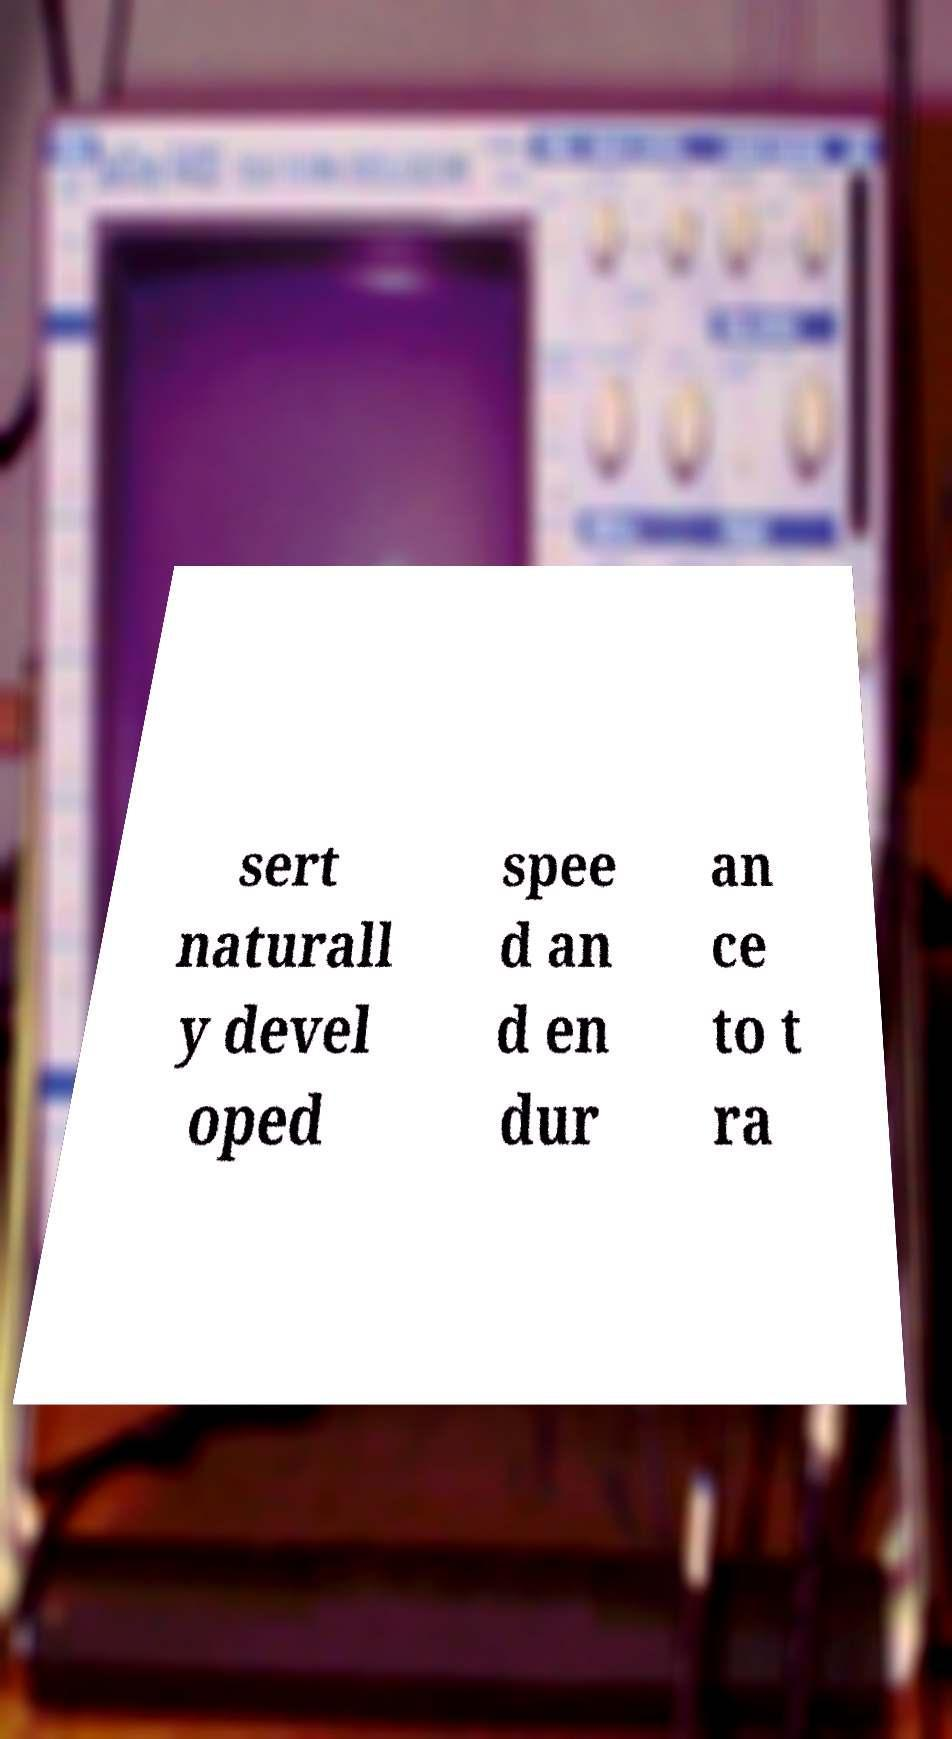Please read and relay the text visible in this image. What does it say? sert naturall y devel oped spee d an d en dur an ce to t ra 